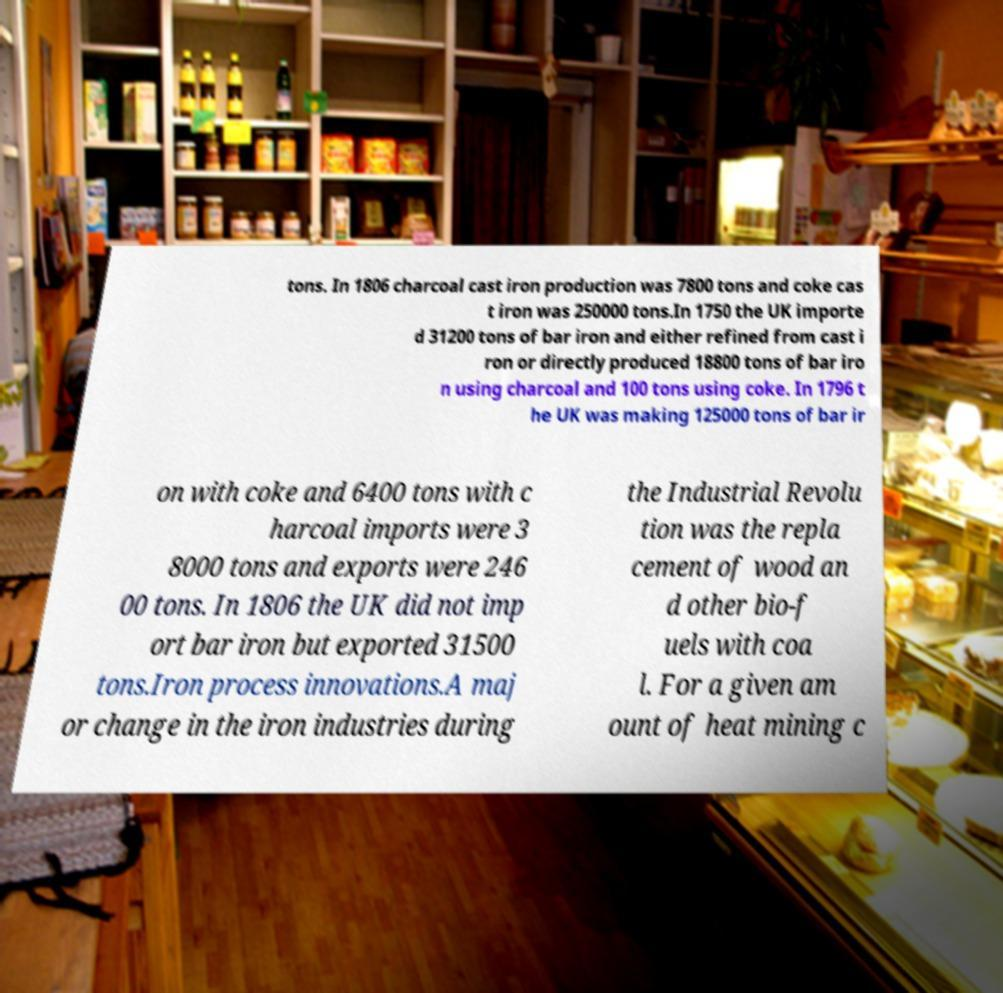Could you extract and type out the text from this image? tons. In 1806 charcoal cast iron production was 7800 tons and coke cas t iron was 250000 tons.In 1750 the UK importe d 31200 tons of bar iron and either refined from cast i ron or directly produced 18800 tons of bar iro n using charcoal and 100 tons using coke. In 1796 t he UK was making 125000 tons of bar ir on with coke and 6400 tons with c harcoal imports were 3 8000 tons and exports were 246 00 tons. In 1806 the UK did not imp ort bar iron but exported 31500 tons.Iron process innovations.A maj or change in the iron industries during the Industrial Revolu tion was the repla cement of wood an d other bio-f uels with coa l. For a given am ount of heat mining c 